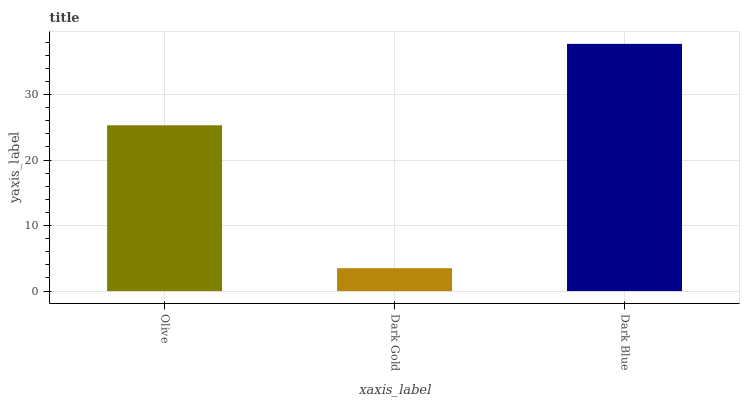Is Dark Gold the minimum?
Answer yes or no. Yes. Is Dark Blue the maximum?
Answer yes or no. Yes. Is Dark Blue the minimum?
Answer yes or no. No. Is Dark Gold the maximum?
Answer yes or no. No. Is Dark Blue greater than Dark Gold?
Answer yes or no. Yes. Is Dark Gold less than Dark Blue?
Answer yes or no. Yes. Is Dark Gold greater than Dark Blue?
Answer yes or no. No. Is Dark Blue less than Dark Gold?
Answer yes or no. No. Is Olive the high median?
Answer yes or no. Yes. Is Olive the low median?
Answer yes or no. Yes. Is Dark Blue the high median?
Answer yes or no. No. Is Dark Gold the low median?
Answer yes or no. No. 